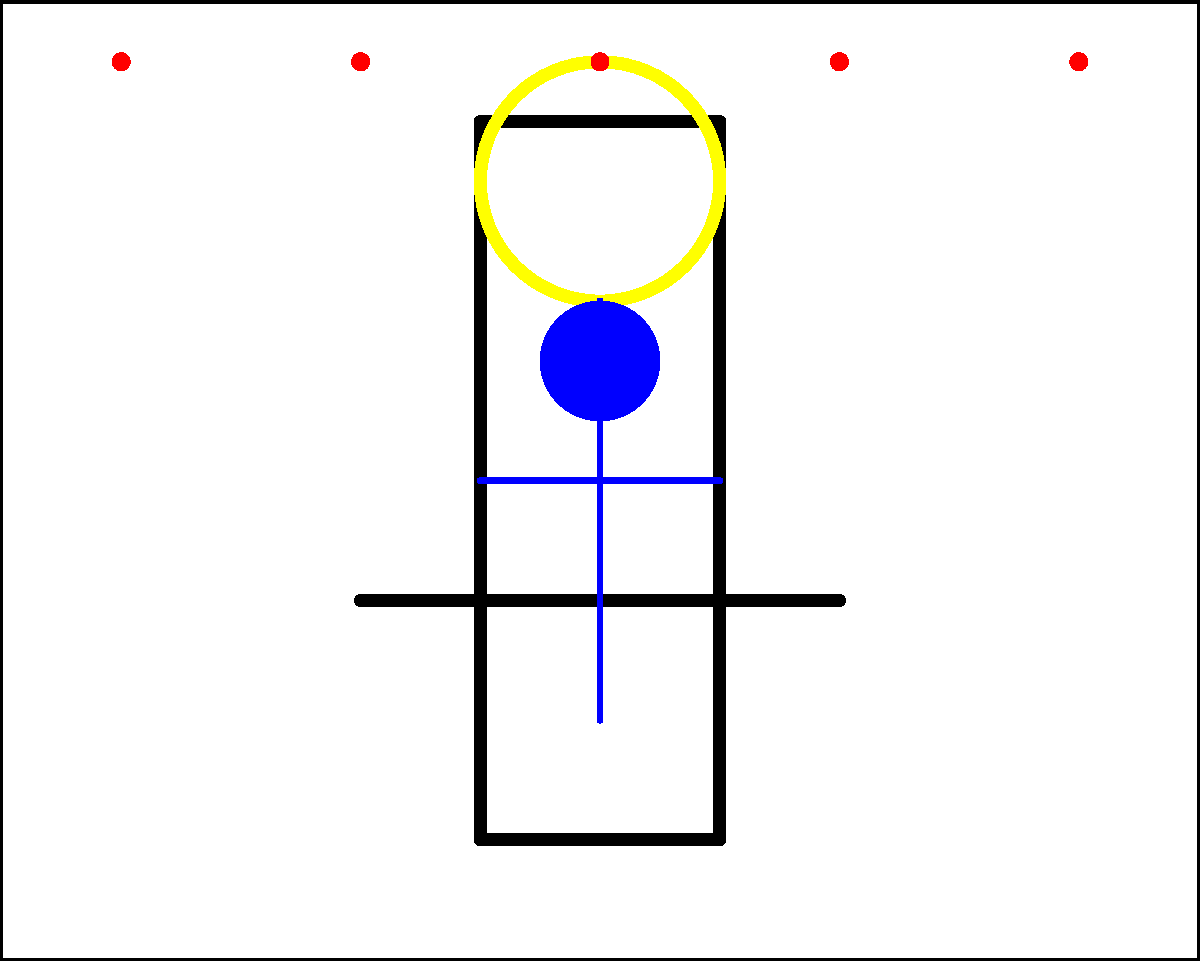In the given medieval religious painting, what does the combination of the cross, halo, and central figure likely represent, and how does this reflect the artistic conventions of the time? To analyze this medieval religious painting, let's break it down step-by-step:

1. Central Elements:
   a. Cross: A large, prominent cross occupies the center of the painting.
   b. Halo: A circular yellow shape appears above the central figure, representing a halo.
   c. Figure: A simplified human figure is positioned in front of the cross.

2. Symbolism:
   a. The cross is a fundamental Christian symbol, representing Christ's crucifixion.
   b. The halo is typically used to denote holiness or divinity in religious art.
   c. The central figure, positioned with arms outstretched, mirrors the shape of the cross.

3. Artistic Conventions:
   a. Use of symbolic elements (cross, halo) was common in medieval religious art.
   b. Simplified, non-naturalistic representation of figures was characteristic of the period.
   c. The composition is symmetrical and hierarchical, emphasizing the central figure.

4. Interpretation:
   The combination of these elements strongly suggests a representation of Jesus Christ. The cross symbolizes his crucifixion, the halo his divinity, and the central position his importance in Christian theology.

5. Historical Context:
   This style of representation was typical in medieval religious art, particularly in icons and altar pieces. It prioritized symbolic meaning over naturalistic depiction, which aligns with the didactic function of religious art in medieval society.

Given these elements and their arrangement, this painting likely represents Jesus Christ as the central figure of Christian worship, employing typical medieval artistic conventions to convey religious meaning.
Answer: Jesus Christ, using medieval symbolic representation 